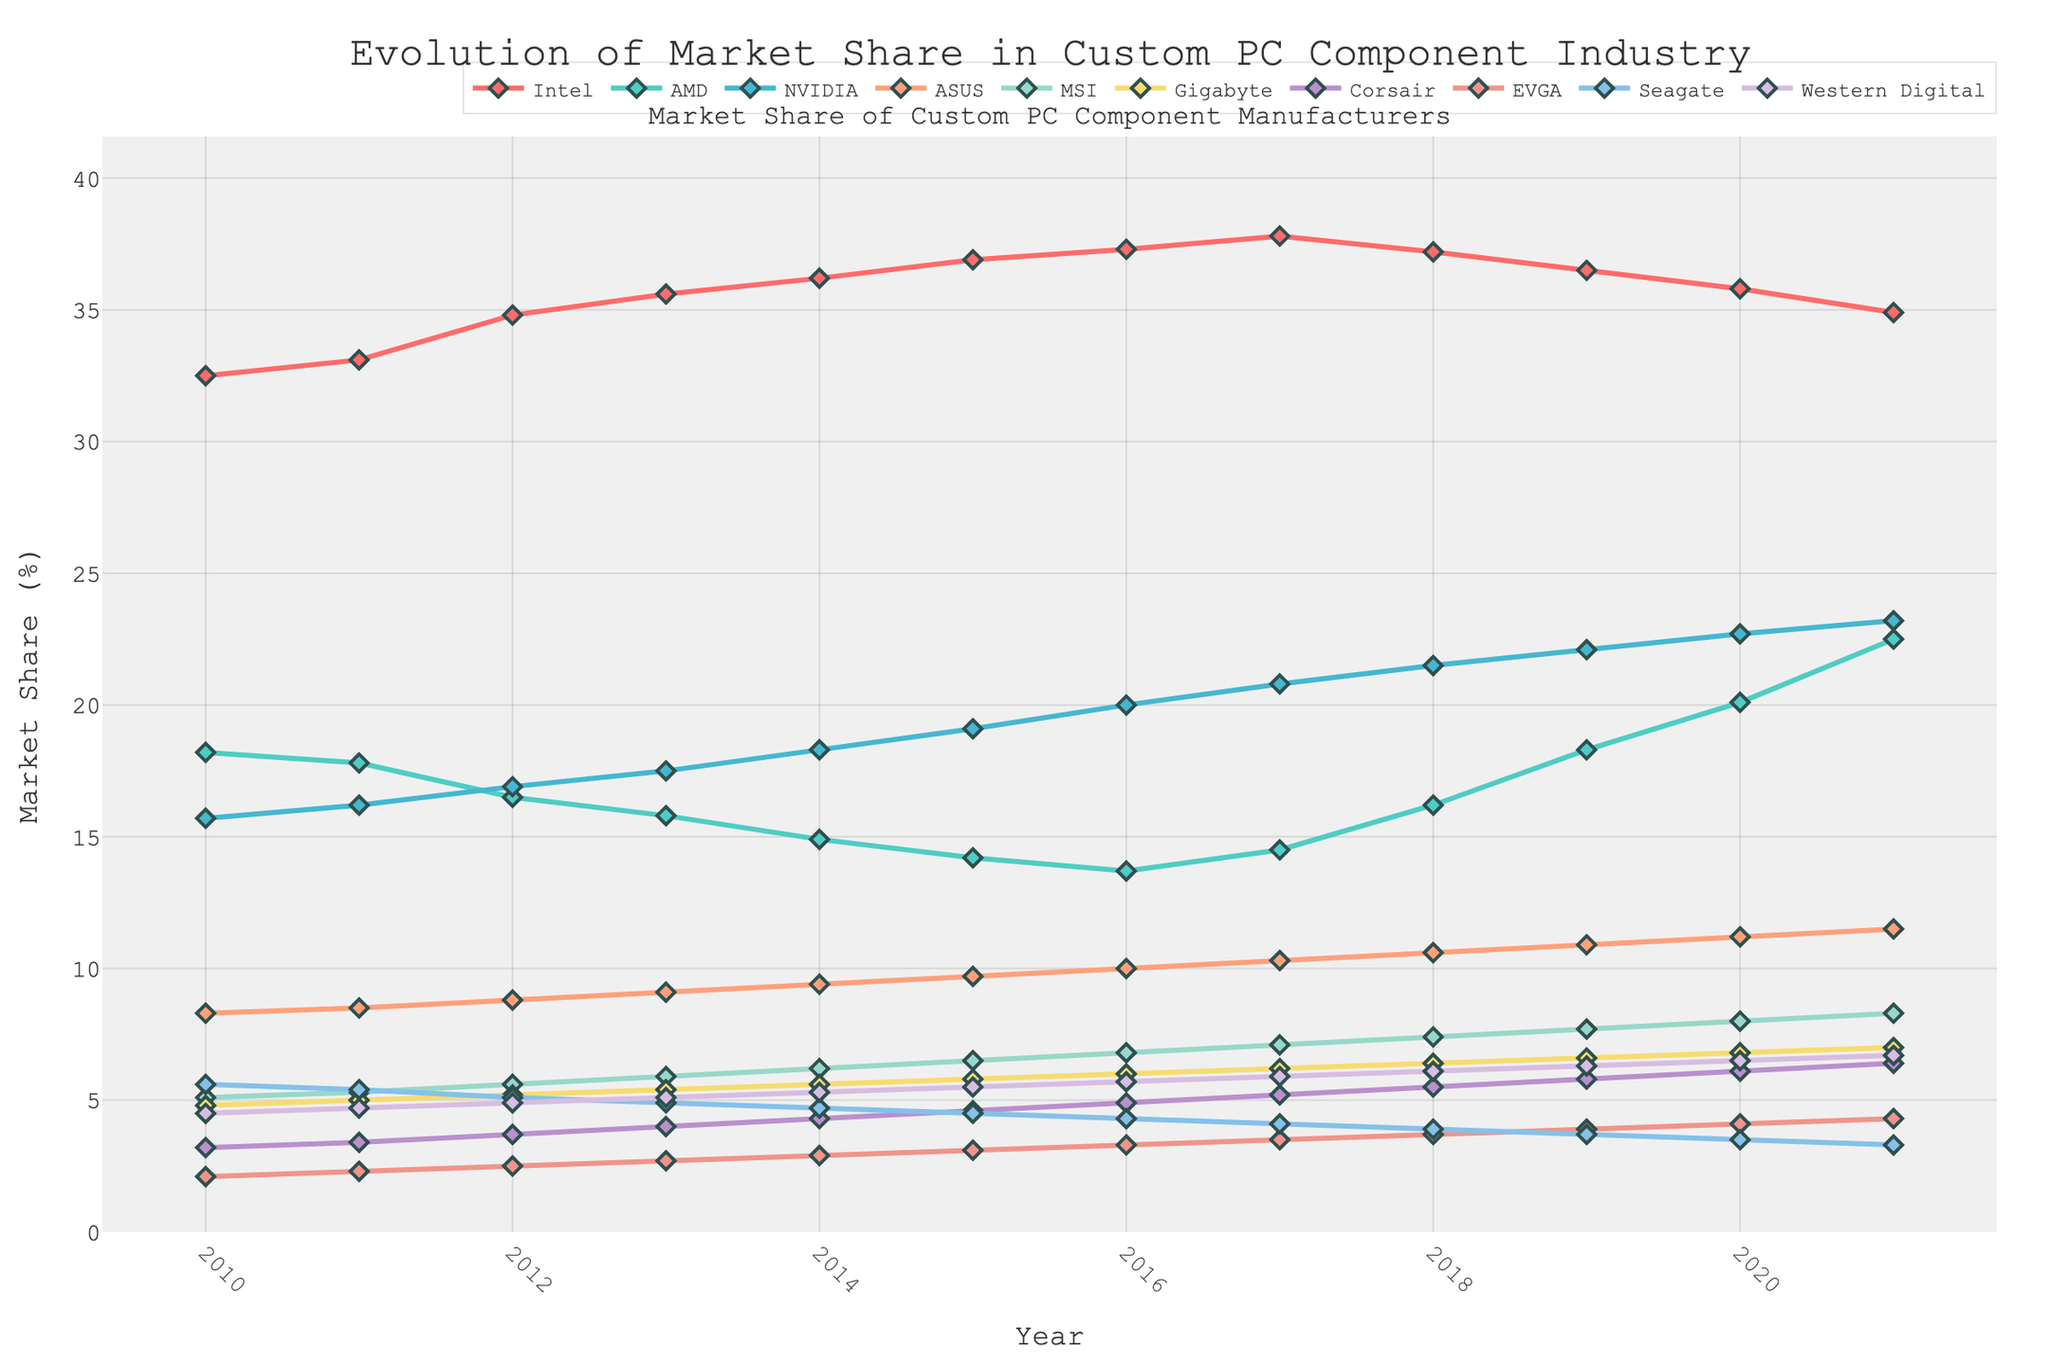What is the average market share of Intel from 2010 to 2021? To find the average market share, sum the market share values for each year from 2010 to 2021 and divide by the number of years (12). The values are 32.5, 33.1, 34.8, 35.6, 36.2, 36.9, 37.3, 37.8, 37.2, 36.5, 35.8, and 34.9. Sum those values: 432.6. Then divide by 12: 432.6/12 = 36.05
Answer: 36.05 Which company had the highest increase in market share from 2010 to 2021? By looking at the data for each year and subtracting the value of 2010 from 2021 for each company, we see: Intel (34.9 - 32.5 = 2.4), AMD (22.5 - 18.2 = 4.3), NVIDIA (23.2 - 15.7 = 7.5), ASUS (11.5 - 8.3 = 3.2), MSI (8.3 - 5.1 = 3.2), Gigabyte (7.0 - 4.8 = 2.2), Corsair (6.4 - 3.2 = 3.2), EVGA (4.3 - 2.1 = 2.2), Seagate (3.3 - 5.6 = -2.3), Western Digital (6.7 - 4.5 = 2.2). NVIDIA has the highest increase: 7.5
Answer: NVIDIA What year did AMD reach its lowest market share in the given period? Looking at the market share values for AMD across the years, the lowest value is 13.7 in 2016.
Answer: 2016 By how much did the market share of Western Digital change between 2010 and 2021? Subtract the market share value of 2010 from 2021 for Western Digital: 6.7 - 4.5 = 2.2. The market share increased by 2.2.
Answer: 2.2 Compare the market share trends of Intel and AMD from 2010 to 2021. Who had the overall declining trend? Plotting both Intel and AMD from 2010 to 2021, Intel’s market share starts at 32.5 and ends at 34.9, while AMD starts at 18.2 and ends at 22.5. Intel generally increases outside of slight drops in 2018 and beyond, but AMD fluctuates more and ultimately sees a larger increase by stepping factors compared to Intel's more stable growth. AMD does not show an overall declining trend.
Answer: Neither What is the difference in market share between NVIDIA and Intel in 2021? Look at the market share values for NVIDIA and Intel in 2021. NVIDIA is 23.2%, and Intel is 34.9%. Subtract NVIDIA's market share from Intel's: 34.9 - 23.2 = 11.7.
Answer: 11.7 Which company had the smallest market share in 2015? Looking at the data for 2015, EVGA has the smallest market share at 3.1%.
Answer: EVGA What trend can be observed in Corsair's market share from 2010 to 2021? By examining Corsair’s data from 2010 (3.2) to 2021 (6.4), we see a consistent and steady increase over the years.
Answer: Steady increase Which companies showed an upward trend throughout the entire period from 2010 to 2021? Analyzing the trends, NVIDIA (15.7 to 23.2) and Western Digital (4.5 to 6.7) show a consistent upward trend.
Answer: NVIDIA, Western Digital How much did the market share of EVGA increase from 2010 to 2021? Calculate the difference between the 2021 and 2010 values of EVGA: 4.3 - 2.1 = 2.2.
Answer: 2.2 